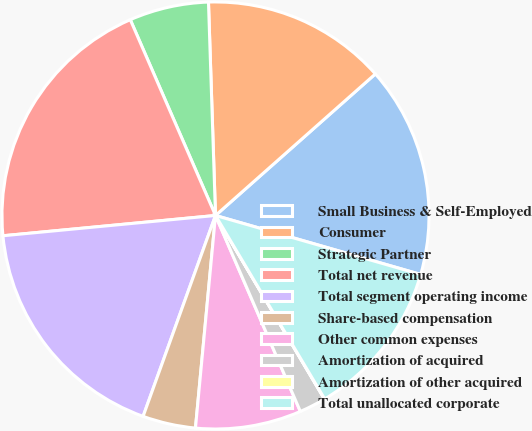Convert chart. <chart><loc_0><loc_0><loc_500><loc_500><pie_chart><fcel>Small Business & Self-Employed<fcel>Consumer<fcel>Strategic Partner<fcel>Total net revenue<fcel>Total segment operating income<fcel>Share-based compensation<fcel>Other common expenses<fcel>Amortization of acquired<fcel>Amortization of other acquired<fcel>Total unallocated corporate<nl><fcel>15.99%<fcel>13.99%<fcel>6.01%<fcel>19.98%<fcel>17.98%<fcel>4.01%<fcel>8.0%<fcel>2.02%<fcel>0.02%<fcel>12.0%<nl></chart> 